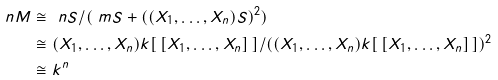<formula> <loc_0><loc_0><loc_500><loc_500>\ n M & \cong \ n S / ( \ m S + ( ( X _ { 1 } , \dots , X _ { n } ) S ) ^ { 2 } ) \\ & \cong ( X _ { 1 } , \dots , X _ { n } ) k [ \, [ X _ { 1 } , \dots , X _ { n } ] \, ] / ( ( X _ { 1 } , \dots , X _ { n } ) k [ \, [ X _ { 1 } , \dots , X _ { n } ] \, ] ) ^ { 2 } \\ & \cong k ^ { n }</formula> 